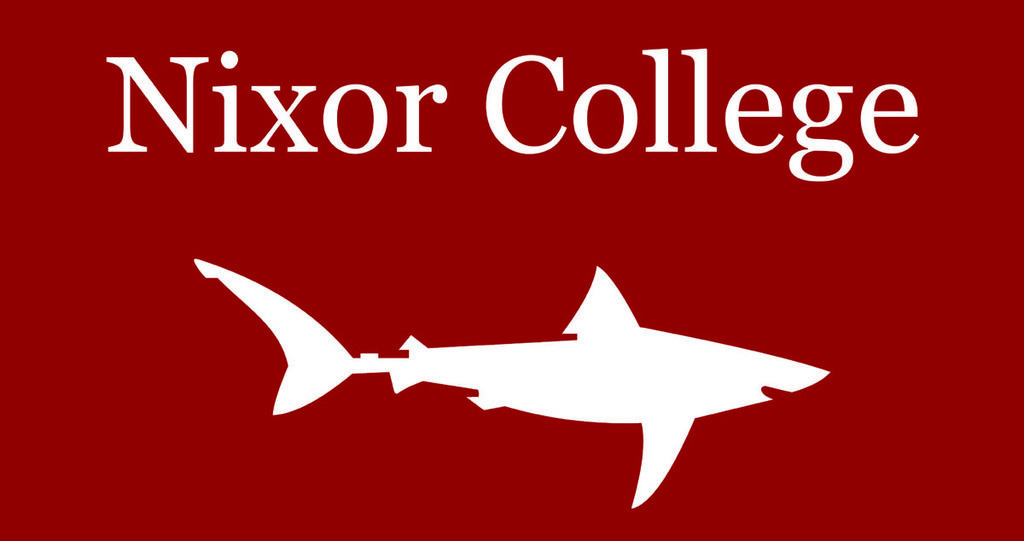What is the color of the poster in the image? The poster in the image is red. What image is drawn on the poster? The poster has a fish print drawn on it. What text is written on the poster? The text "Nixor College" is written above the fish print. What type of attraction can be seen in the background of the image? There is no attraction visible in the image; it only features a red color poster with a fish print and the text "Nixor College." 